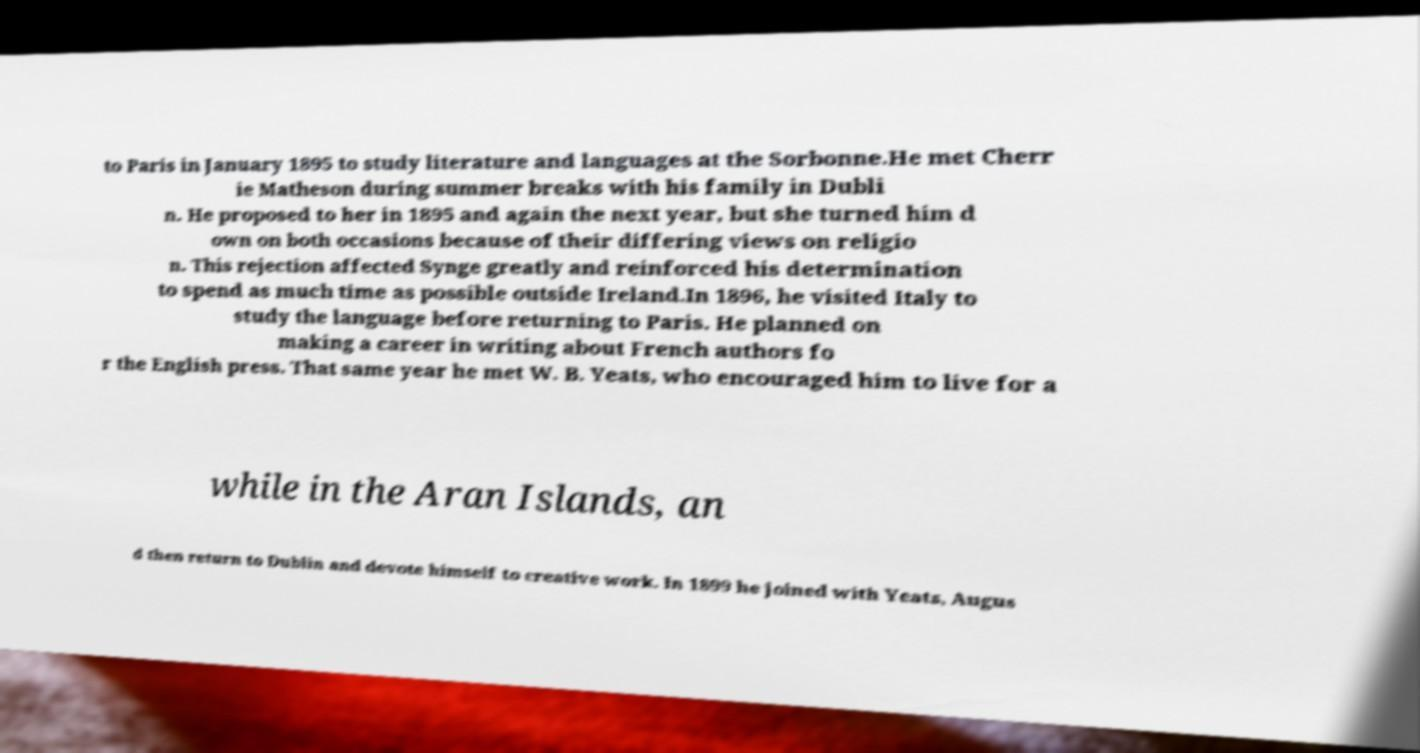Please read and relay the text visible in this image. What does it say? to Paris in January 1895 to study literature and languages at the Sorbonne.He met Cherr ie Matheson during summer breaks with his family in Dubli n. He proposed to her in 1895 and again the next year, but she turned him d own on both occasions because of their differing views on religio n. This rejection affected Synge greatly and reinforced his determination to spend as much time as possible outside Ireland.In 1896, he visited Italy to study the language before returning to Paris. He planned on making a career in writing about French authors fo r the English press. That same year he met W. B. Yeats, who encouraged him to live for a while in the Aran Islands, an d then return to Dublin and devote himself to creative work. In 1899 he joined with Yeats, Augus 